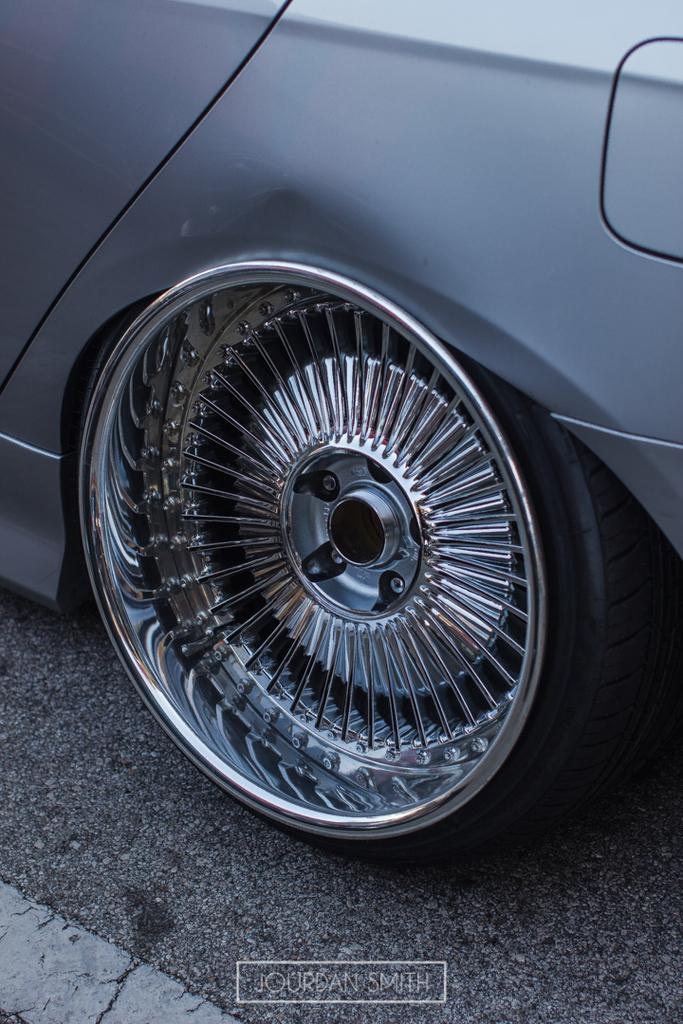What is the main subject of the image? There is a vehicle in the image. Where is the vehicle located? The vehicle is on a road. Can you describe the composition of the image? The image is cropped, showing only a portion of the scene. What degree does the vehicle have in the image? The vehicle does not have a degree; it is an inanimate object. Is there a partner visible in the image? There is no partner present in the image. 